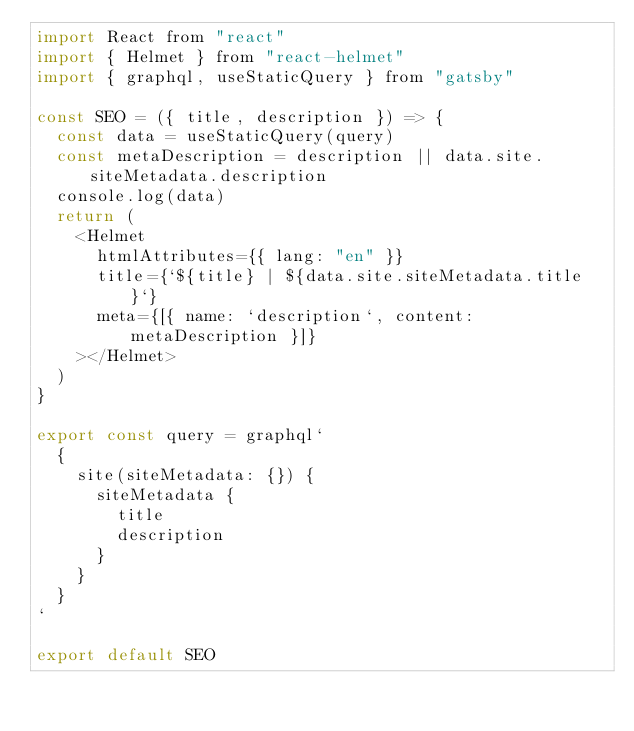Convert code to text. <code><loc_0><loc_0><loc_500><loc_500><_JavaScript_>import React from "react"
import { Helmet } from "react-helmet"
import { graphql, useStaticQuery } from "gatsby"

const SEO = ({ title, description }) => {
  const data = useStaticQuery(query)
  const metaDescription = description || data.site.siteMetadata.description
  console.log(data)
  return (
    <Helmet
      htmlAttributes={{ lang: "en" }}
      title={`${title} | ${data.site.siteMetadata.title}`}
      meta={[{ name: `description`, content: metaDescription }]}
    ></Helmet>
  )
}

export const query = graphql`
  {
    site(siteMetadata: {}) {
      siteMetadata {
        title
        description
      }
    }
  }
`

export default SEO
</code> 